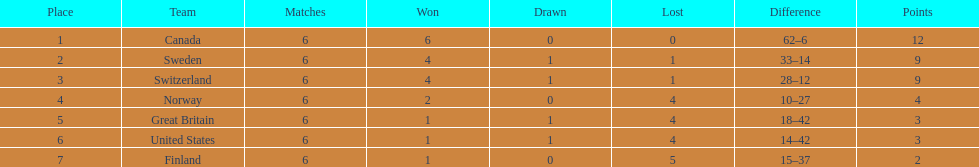In the 1951 world ice hockey championships, did switzerland or great britain have a better performance? Switzerland. 